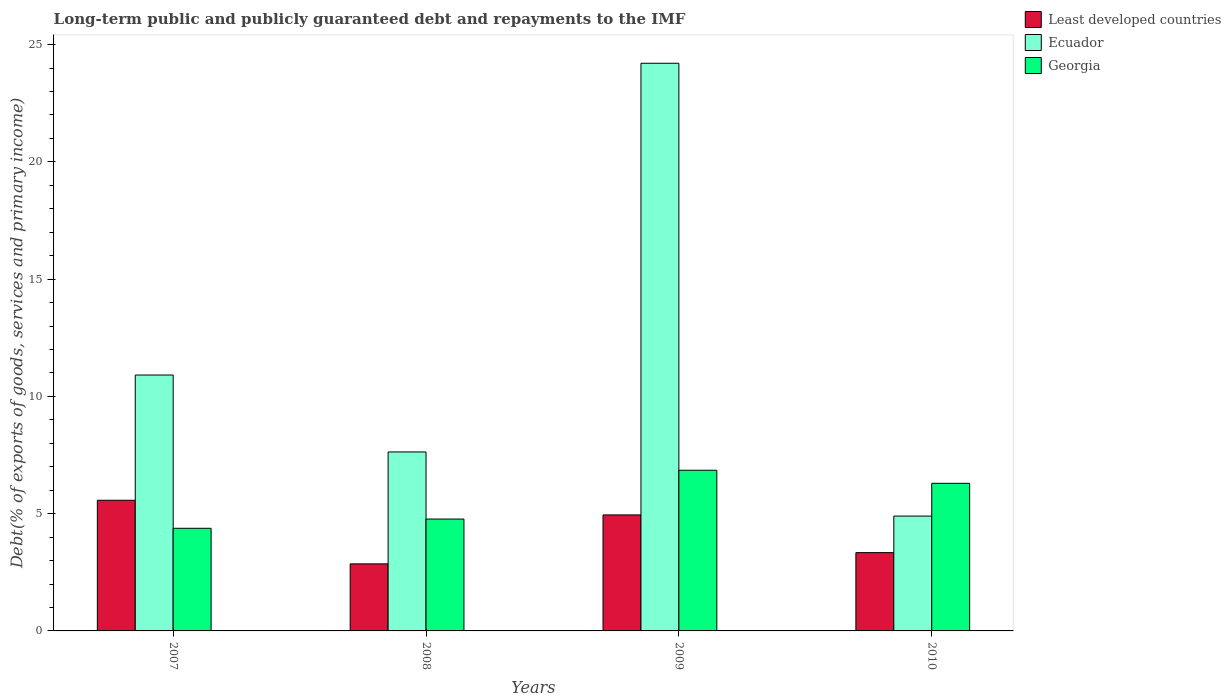How many different coloured bars are there?
Your answer should be compact. 3. How many groups of bars are there?
Offer a terse response. 4. Are the number of bars per tick equal to the number of legend labels?
Make the answer very short. Yes. In how many cases, is the number of bars for a given year not equal to the number of legend labels?
Your answer should be compact. 0. What is the debt and repayments in Georgia in 2009?
Provide a short and direct response. 6.85. Across all years, what is the maximum debt and repayments in Least developed countries?
Your response must be concise. 5.57. Across all years, what is the minimum debt and repayments in Georgia?
Your answer should be very brief. 4.38. In which year was the debt and repayments in Ecuador maximum?
Make the answer very short. 2009. In which year was the debt and repayments in Least developed countries minimum?
Offer a very short reply. 2008. What is the total debt and repayments in Ecuador in the graph?
Your response must be concise. 47.64. What is the difference between the debt and repayments in Georgia in 2008 and that in 2010?
Provide a succinct answer. -1.52. What is the difference between the debt and repayments in Georgia in 2010 and the debt and repayments in Least developed countries in 2009?
Your answer should be very brief. 1.35. What is the average debt and repayments in Ecuador per year?
Keep it short and to the point. 11.91. In the year 2007, what is the difference between the debt and repayments in Least developed countries and debt and repayments in Ecuador?
Keep it short and to the point. -5.34. What is the ratio of the debt and repayments in Least developed countries in 2007 to that in 2010?
Your answer should be very brief. 1.67. Is the debt and repayments in Ecuador in 2008 less than that in 2010?
Provide a short and direct response. No. Is the difference between the debt and repayments in Least developed countries in 2009 and 2010 greater than the difference between the debt and repayments in Ecuador in 2009 and 2010?
Keep it short and to the point. No. What is the difference between the highest and the second highest debt and repayments in Least developed countries?
Provide a short and direct response. 0.62. What is the difference between the highest and the lowest debt and repayments in Georgia?
Your answer should be very brief. 2.47. In how many years, is the debt and repayments in Georgia greater than the average debt and repayments in Georgia taken over all years?
Make the answer very short. 2. What does the 2nd bar from the left in 2007 represents?
Give a very brief answer. Ecuador. What does the 1st bar from the right in 2008 represents?
Keep it short and to the point. Georgia. Is it the case that in every year, the sum of the debt and repayments in Least developed countries and debt and repayments in Georgia is greater than the debt and repayments in Ecuador?
Keep it short and to the point. No. How many bars are there?
Give a very brief answer. 12. How many years are there in the graph?
Ensure brevity in your answer.  4. What is the difference between two consecutive major ticks on the Y-axis?
Provide a succinct answer. 5. Does the graph contain grids?
Your answer should be very brief. No. Where does the legend appear in the graph?
Keep it short and to the point. Top right. How many legend labels are there?
Give a very brief answer. 3. What is the title of the graph?
Provide a short and direct response. Long-term public and publicly guaranteed debt and repayments to the IMF. What is the label or title of the X-axis?
Offer a very short reply. Years. What is the label or title of the Y-axis?
Your answer should be compact. Debt(% of exports of goods, services and primary income). What is the Debt(% of exports of goods, services and primary income) in Least developed countries in 2007?
Give a very brief answer. 5.57. What is the Debt(% of exports of goods, services and primary income) of Ecuador in 2007?
Your response must be concise. 10.91. What is the Debt(% of exports of goods, services and primary income) in Georgia in 2007?
Your response must be concise. 4.38. What is the Debt(% of exports of goods, services and primary income) in Least developed countries in 2008?
Provide a succinct answer. 2.86. What is the Debt(% of exports of goods, services and primary income) in Ecuador in 2008?
Offer a very short reply. 7.63. What is the Debt(% of exports of goods, services and primary income) of Georgia in 2008?
Provide a succinct answer. 4.77. What is the Debt(% of exports of goods, services and primary income) in Least developed countries in 2009?
Your answer should be very brief. 4.95. What is the Debt(% of exports of goods, services and primary income) in Ecuador in 2009?
Give a very brief answer. 24.2. What is the Debt(% of exports of goods, services and primary income) in Georgia in 2009?
Make the answer very short. 6.85. What is the Debt(% of exports of goods, services and primary income) of Least developed countries in 2010?
Make the answer very short. 3.34. What is the Debt(% of exports of goods, services and primary income) in Ecuador in 2010?
Offer a very short reply. 4.9. What is the Debt(% of exports of goods, services and primary income) in Georgia in 2010?
Your answer should be compact. 6.29. Across all years, what is the maximum Debt(% of exports of goods, services and primary income) in Least developed countries?
Your answer should be compact. 5.57. Across all years, what is the maximum Debt(% of exports of goods, services and primary income) of Ecuador?
Your answer should be very brief. 24.2. Across all years, what is the maximum Debt(% of exports of goods, services and primary income) in Georgia?
Your response must be concise. 6.85. Across all years, what is the minimum Debt(% of exports of goods, services and primary income) in Least developed countries?
Your answer should be very brief. 2.86. Across all years, what is the minimum Debt(% of exports of goods, services and primary income) in Ecuador?
Your response must be concise. 4.9. Across all years, what is the minimum Debt(% of exports of goods, services and primary income) of Georgia?
Provide a short and direct response. 4.38. What is the total Debt(% of exports of goods, services and primary income) of Least developed countries in the graph?
Provide a short and direct response. 16.71. What is the total Debt(% of exports of goods, services and primary income) in Ecuador in the graph?
Keep it short and to the point. 47.64. What is the total Debt(% of exports of goods, services and primary income) of Georgia in the graph?
Offer a terse response. 22.29. What is the difference between the Debt(% of exports of goods, services and primary income) of Least developed countries in 2007 and that in 2008?
Your answer should be compact. 2.71. What is the difference between the Debt(% of exports of goods, services and primary income) in Ecuador in 2007 and that in 2008?
Provide a short and direct response. 3.28. What is the difference between the Debt(% of exports of goods, services and primary income) of Georgia in 2007 and that in 2008?
Offer a very short reply. -0.39. What is the difference between the Debt(% of exports of goods, services and primary income) in Least developed countries in 2007 and that in 2009?
Give a very brief answer. 0.62. What is the difference between the Debt(% of exports of goods, services and primary income) of Ecuador in 2007 and that in 2009?
Offer a very short reply. -13.29. What is the difference between the Debt(% of exports of goods, services and primary income) in Georgia in 2007 and that in 2009?
Provide a succinct answer. -2.47. What is the difference between the Debt(% of exports of goods, services and primary income) in Least developed countries in 2007 and that in 2010?
Give a very brief answer. 2.23. What is the difference between the Debt(% of exports of goods, services and primary income) of Ecuador in 2007 and that in 2010?
Give a very brief answer. 6.01. What is the difference between the Debt(% of exports of goods, services and primary income) of Georgia in 2007 and that in 2010?
Provide a short and direct response. -1.92. What is the difference between the Debt(% of exports of goods, services and primary income) in Least developed countries in 2008 and that in 2009?
Ensure brevity in your answer.  -2.09. What is the difference between the Debt(% of exports of goods, services and primary income) in Ecuador in 2008 and that in 2009?
Make the answer very short. -16.57. What is the difference between the Debt(% of exports of goods, services and primary income) of Georgia in 2008 and that in 2009?
Your response must be concise. -2.08. What is the difference between the Debt(% of exports of goods, services and primary income) in Least developed countries in 2008 and that in 2010?
Ensure brevity in your answer.  -0.48. What is the difference between the Debt(% of exports of goods, services and primary income) in Ecuador in 2008 and that in 2010?
Provide a short and direct response. 2.73. What is the difference between the Debt(% of exports of goods, services and primary income) in Georgia in 2008 and that in 2010?
Offer a terse response. -1.52. What is the difference between the Debt(% of exports of goods, services and primary income) in Least developed countries in 2009 and that in 2010?
Provide a succinct answer. 1.61. What is the difference between the Debt(% of exports of goods, services and primary income) in Ecuador in 2009 and that in 2010?
Your answer should be compact. 19.31. What is the difference between the Debt(% of exports of goods, services and primary income) in Georgia in 2009 and that in 2010?
Your answer should be very brief. 0.56. What is the difference between the Debt(% of exports of goods, services and primary income) in Least developed countries in 2007 and the Debt(% of exports of goods, services and primary income) in Ecuador in 2008?
Give a very brief answer. -2.06. What is the difference between the Debt(% of exports of goods, services and primary income) of Least developed countries in 2007 and the Debt(% of exports of goods, services and primary income) of Georgia in 2008?
Ensure brevity in your answer.  0.8. What is the difference between the Debt(% of exports of goods, services and primary income) of Ecuador in 2007 and the Debt(% of exports of goods, services and primary income) of Georgia in 2008?
Your response must be concise. 6.14. What is the difference between the Debt(% of exports of goods, services and primary income) in Least developed countries in 2007 and the Debt(% of exports of goods, services and primary income) in Ecuador in 2009?
Keep it short and to the point. -18.63. What is the difference between the Debt(% of exports of goods, services and primary income) in Least developed countries in 2007 and the Debt(% of exports of goods, services and primary income) in Georgia in 2009?
Your response must be concise. -1.28. What is the difference between the Debt(% of exports of goods, services and primary income) in Ecuador in 2007 and the Debt(% of exports of goods, services and primary income) in Georgia in 2009?
Offer a terse response. 4.06. What is the difference between the Debt(% of exports of goods, services and primary income) in Least developed countries in 2007 and the Debt(% of exports of goods, services and primary income) in Ecuador in 2010?
Provide a succinct answer. 0.67. What is the difference between the Debt(% of exports of goods, services and primary income) in Least developed countries in 2007 and the Debt(% of exports of goods, services and primary income) in Georgia in 2010?
Ensure brevity in your answer.  -0.72. What is the difference between the Debt(% of exports of goods, services and primary income) in Ecuador in 2007 and the Debt(% of exports of goods, services and primary income) in Georgia in 2010?
Make the answer very short. 4.62. What is the difference between the Debt(% of exports of goods, services and primary income) in Least developed countries in 2008 and the Debt(% of exports of goods, services and primary income) in Ecuador in 2009?
Offer a very short reply. -21.34. What is the difference between the Debt(% of exports of goods, services and primary income) of Least developed countries in 2008 and the Debt(% of exports of goods, services and primary income) of Georgia in 2009?
Offer a very short reply. -3.99. What is the difference between the Debt(% of exports of goods, services and primary income) in Ecuador in 2008 and the Debt(% of exports of goods, services and primary income) in Georgia in 2009?
Offer a terse response. 0.78. What is the difference between the Debt(% of exports of goods, services and primary income) in Least developed countries in 2008 and the Debt(% of exports of goods, services and primary income) in Ecuador in 2010?
Your answer should be very brief. -2.04. What is the difference between the Debt(% of exports of goods, services and primary income) of Least developed countries in 2008 and the Debt(% of exports of goods, services and primary income) of Georgia in 2010?
Provide a succinct answer. -3.43. What is the difference between the Debt(% of exports of goods, services and primary income) of Ecuador in 2008 and the Debt(% of exports of goods, services and primary income) of Georgia in 2010?
Offer a very short reply. 1.34. What is the difference between the Debt(% of exports of goods, services and primary income) of Least developed countries in 2009 and the Debt(% of exports of goods, services and primary income) of Ecuador in 2010?
Provide a short and direct response. 0.05. What is the difference between the Debt(% of exports of goods, services and primary income) in Least developed countries in 2009 and the Debt(% of exports of goods, services and primary income) in Georgia in 2010?
Keep it short and to the point. -1.35. What is the difference between the Debt(% of exports of goods, services and primary income) in Ecuador in 2009 and the Debt(% of exports of goods, services and primary income) in Georgia in 2010?
Give a very brief answer. 17.91. What is the average Debt(% of exports of goods, services and primary income) of Least developed countries per year?
Offer a terse response. 4.18. What is the average Debt(% of exports of goods, services and primary income) in Ecuador per year?
Your response must be concise. 11.91. What is the average Debt(% of exports of goods, services and primary income) in Georgia per year?
Your response must be concise. 5.57. In the year 2007, what is the difference between the Debt(% of exports of goods, services and primary income) of Least developed countries and Debt(% of exports of goods, services and primary income) of Ecuador?
Make the answer very short. -5.34. In the year 2007, what is the difference between the Debt(% of exports of goods, services and primary income) of Least developed countries and Debt(% of exports of goods, services and primary income) of Georgia?
Make the answer very short. 1.2. In the year 2007, what is the difference between the Debt(% of exports of goods, services and primary income) in Ecuador and Debt(% of exports of goods, services and primary income) in Georgia?
Provide a short and direct response. 6.53. In the year 2008, what is the difference between the Debt(% of exports of goods, services and primary income) in Least developed countries and Debt(% of exports of goods, services and primary income) in Ecuador?
Keep it short and to the point. -4.77. In the year 2008, what is the difference between the Debt(% of exports of goods, services and primary income) in Least developed countries and Debt(% of exports of goods, services and primary income) in Georgia?
Give a very brief answer. -1.91. In the year 2008, what is the difference between the Debt(% of exports of goods, services and primary income) of Ecuador and Debt(% of exports of goods, services and primary income) of Georgia?
Your answer should be very brief. 2.86. In the year 2009, what is the difference between the Debt(% of exports of goods, services and primary income) of Least developed countries and Debt(% of exports of goods, services and primary income) of Ecuador?
Your answer should be very brief. -19.26. In the year 2009, what is the difference between the Debt(% of exports of goods, services and primary income) in Least developed countries and Debt(% of exports of goods, services and primary income) in Georgia?
Provide a short and direct response. -1.9. In the year 2009, what is the difference between the Debt(% of exports of goods, services and primary income) of Ecuador and Debt(% of exports of goods, services and primary income) of Georgia?
Your response must be concise. 17.35. In the year 2010, what is the difference between the Debt(% of exports of goods, services and primary income) of Least developed countries and Debt(% of exports of goods, services and primary income) of Ecuador?
Your response must be concise. -1.56. In the year 2010, what is the difference between the Debt(% of exports of goods, services and primary income) in Least developed countries and Debt(% of exports of goods, services and primary income) in Georgia?
Provide a succinct answer. -2.96. In the year 2010, what is the difference between the Debt(% of exports of goods, services and primary income) in Ecuador and Debt(% of exports of goods, services and primary income) in Georgia?
Keep it short and to the point. -1.4. What is the ratio of the Debt(% of exports of goods, services and primary income) in Least developed countries in 2007 to that in 2008?
Ensure brevity in your answer.  1.95. What is the ratio of the Debt(% of exports of goods, services and primary income) in Ecuador in 2007 to that in 2008?
Keep it short and to the point. 1.43. What is the ratio of the Debt(% of exports of goods, services and primary income) in Georgia in 2007 to that in 2008?
Provide a short and direct response. 0.92. What is the ratio of the Debt(% of exports of goods, services and primary income) in Least developed countries in 2007 to that in 2009?
Keep it short and to the point. 1.13. What is the ratio of the Debt(% of exports of goods, services and primary income) in Ecuador in 2007 to that in 2009?
Your answer should be very brief. 0.45. What is the ratio of the Debt(% of exports of goods, services and primary income) of Georgia in 2007 to that in 2009?
Offer a very short reply. 0.64. What is the ratio of the Debt(% of exports of goods, services and primary income) in Least developed countries in 2007 to that in 2010?
Provide a succinct answer. 1.67. What is the ratio of the Debt(% of exports of goods, services and primary income) in Ecuador in 2007 to that in 2010?
Your response must be concise. 2.23. What is the ratio of the Debt(% of exports of goods, services and primary income) of Georgia in 2007 to that in 2010?
Your answer should be very brief. 0.7. What is the ratio of the Debt(% of exports of goods, services and primary income) in Least developed countries in 2008 to that in 2009?
Make the answer very short. 0.58. What is the ratio of the Debt(% of exports of goods, services and primary income) of Ecuador in 2008 to that in 2009?
Provide a succinct answer. 0.32. What is the ratio of the Debt(% of exports of goods, services and primary income) in Georgia in 2008 to that in 2009?
Offer a very short reply. 0.7. What is the ratio of the Debt(% of exports of goods, services and primary income) in Least developed countries in 2008 to that in 2010?
Your answer should be very brief. 0.86. What is the ratio of the Debt(% of exports of goods, services and primary income) of Ecuador in 2008 to that in 2010?
Keep it short and to the point. 1.56. What is the ratio of the Debt(% of exports of goods, services and primary income) in Georgia in 2008 to that in 2010?
Offer a very short reply. 0.76. What is the ratio of the Debt(% of exports of goods, services and primary income) in Least developed countries in 2009 to that in 2010?
Your response must be concise. 1.48. What is the ratio of the Debt(% of exports of goods, services and primary income) of Ecuador in 2009 to that in 2010?
Give a very brief answer. 4.94. What is the ratio of the Debt(% of exports of goods, services and primary income) in Georgia in 2009 to that in 2010?
Provide a short and direct response. 1.09. What is the difference between the highest and the second highest Debt(% of exports of goods, services and primary income) in Least developed countries?
Offer a terse response. 0.62. What is the difference between the highest and the second highest Debt(% of exports of goods, services and primary income) of Ecuador?
Make the answer very short. 13.29. What is the difference between the highest and the second highest Debt(% of exports of goods, services and primary income) of Georgia?
Keep it short and to the point. 0.56. What is the difference between the highest and the lowest Debt(% of exports of goods, services and primary income) in Least developed countries?
Give a very brief answer. 2.71. What is the difference between the highest and the lowest Debt(% of exports of goods, services and primary income) of Ecuador?
Offer a very short reply. 19.31. What is the difference between the highest and the lowest Debt(% of exports of goods, services and primary income) of Georgia?
Ensure brevity in your answer.  2.47. 